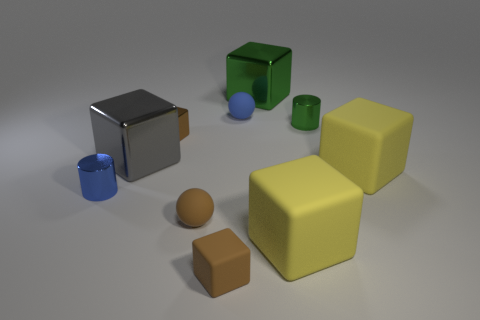Subtract all yellow matte blocks. How many blocks are left? 4 Subtract all green blocks. How many blocks are left? 5 Subtract 1 spheres. How many spheres are left? 1 Subtract 1 green cylinders. How many objects are left? 9 Subtract all spheres. How many objects are left? 8 Subtract all purple balls. Subtract all red cylinders. How many balls are left? 2 Subtract all yellow cylinders. How many cyan spheres are left? 0 Subtract all big yellow matte objects. Subtract all small matte spheres. How many objects are left? 6 Add 9 big gray things. How many big gray things are left? 10 Add 2 cyan shiny objects. How many cyan shiny objects exist? 2 